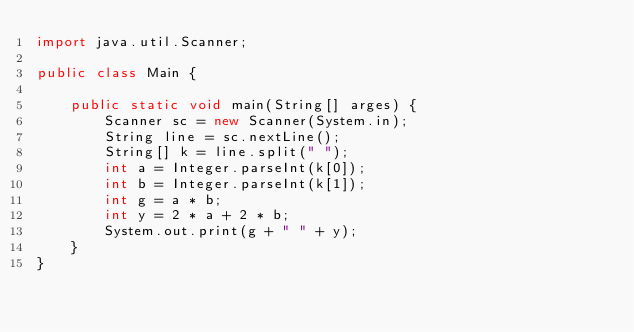Convert code to text. <code><loc_0><loc_0><loc_500><loc_500><_Java_>import java.util.Scanner;

public class Main {

	public static void main(String[] arges) {
		Scanner sc = new Scanner(System.in);
		String line = sc.nextLine();
		String[] k = line.split(" ");
		int a = Integer.parseInt(k[0]);
		int b = Integer.parseInt(k[1]);
		int g = a * b;
		int y = 2 * a + 2 * b;
		System.out.print(g + " " + y);
	}
}</code> 